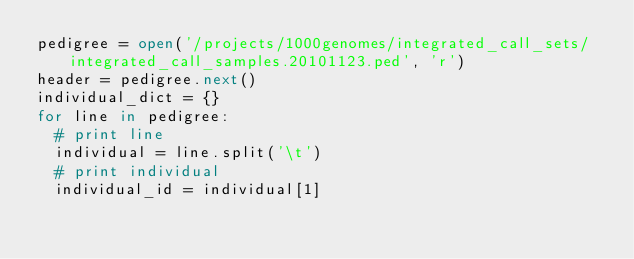Convert code to text. <code><loc_0><loc_0><loc_500><loc_500><_Python_>pedigree = open('/projects/1000genomes/integrated_call_sets/integrated_call_samples.20101123.ped', 'r')
header = pedigree.next()
individual_dict = {}
for line in pedigree:
	# print line
	individual = line.split('\t')
	# print individual
	individual_id = individual[1]</code> 